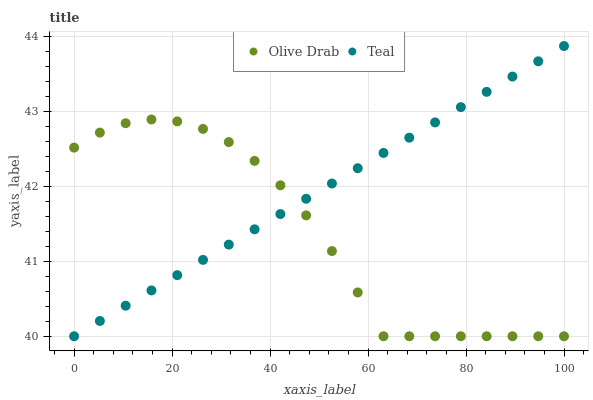Does Olive Drab have the minimum area under the curve?
Answer yes or no. Yes. Does Teal have the maximum area under the curve?
Answer yes or no. Yes. Does Olive Drab have the maximum area under the curve?
Answer yes or no. No. Is Teal the smoothest?
Answer yes or no. Yes. Is Olive Drab the roughest?
Answer yes or no. Yes. Is Olive Drab the smoothest?
Answer yes or no. No. Does Teal have the lowest value?
Answer yes or no. Yes. Does Teal have the highest value?
Answer yes or no. Yes. Does Olive Drab have the highest value?
Answer yes or no. No. Does Teal intersect Olive Drab?
Answer yes or no. Yes. Is Teal less than Olive Drab?
Answer yes or no. No. Is Teal greater than Olive Drab?
Answer yes or no. No. 